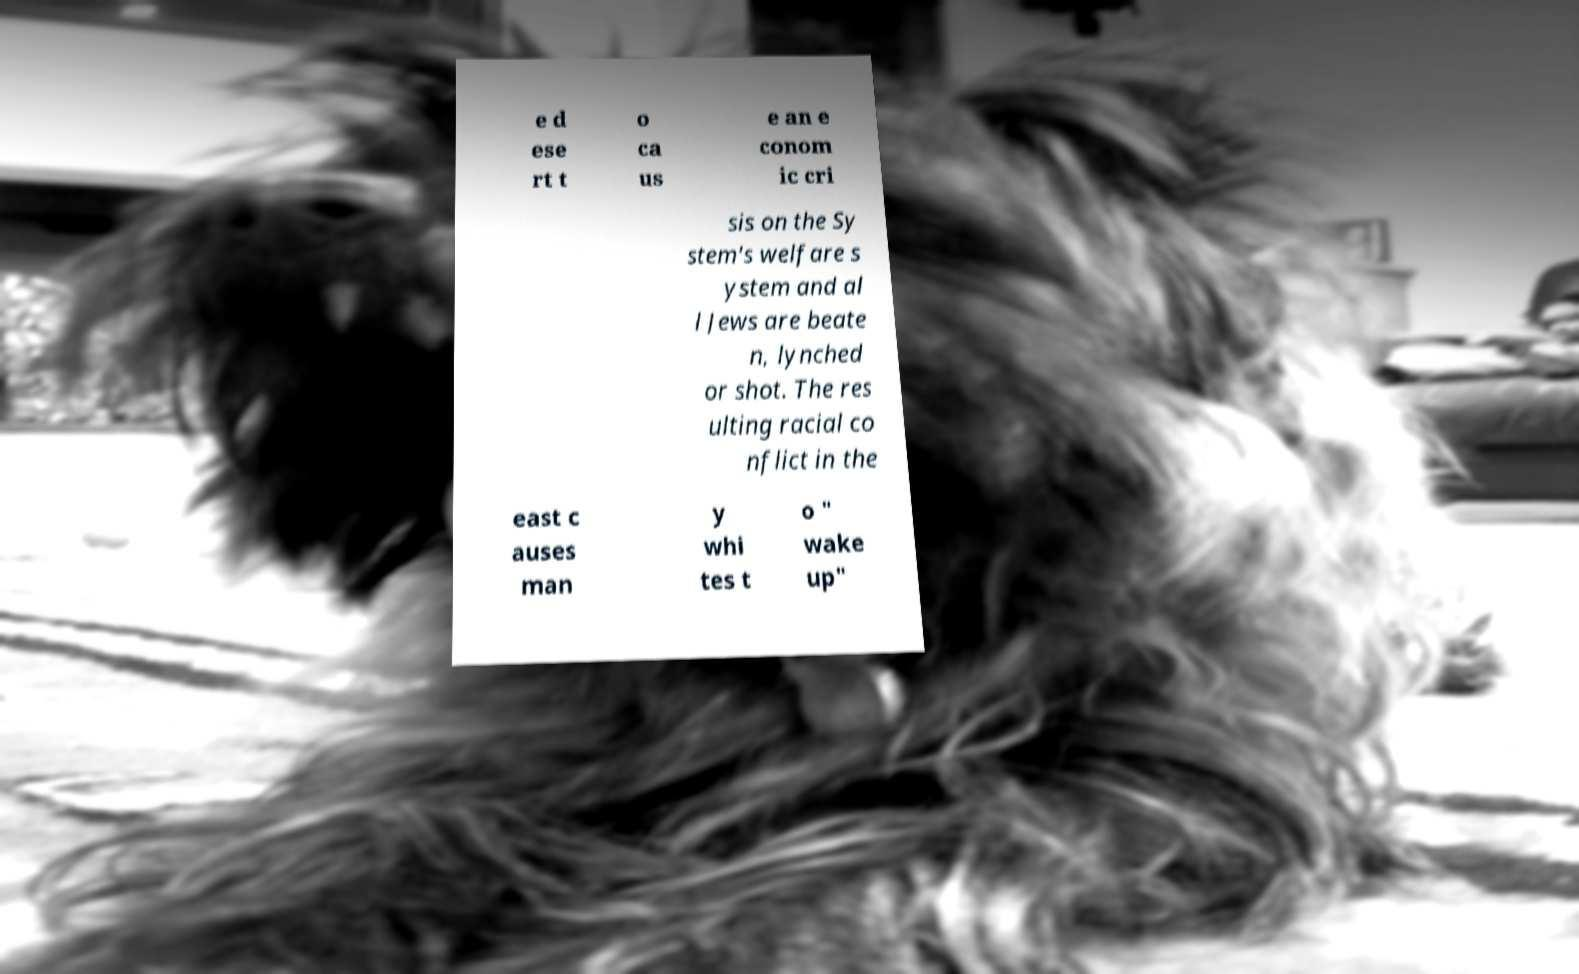Could you extract and type out the text from this image? e d ese rt t o ca us e an e conom ic cri sis on the Sy stem's welfare s ystem and al l Jews are beate n, lynched or shot. The res ulting racial co nflict in the east c auses man y whi tes t o " wake up" 